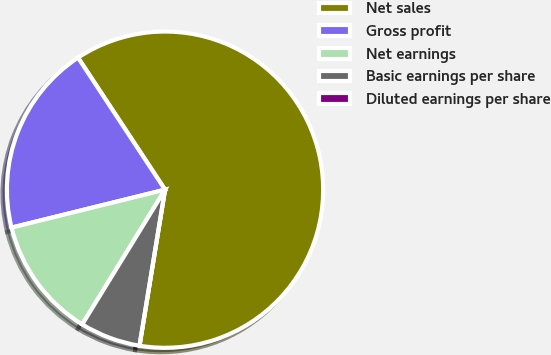<chart> <loc_0><loc_0><loc_500><loc_500><pie_chart><fcel>Net sales<fcel>Gross profit<fcel>Net earnings<fcel>Basic earnings per share<fcel>Diluted earnings per share<nl><fcel>61.86%<fcel>19.58%<fcel>12.37%<fcel>6.19%<fcel>0.0%<nl></chart> 